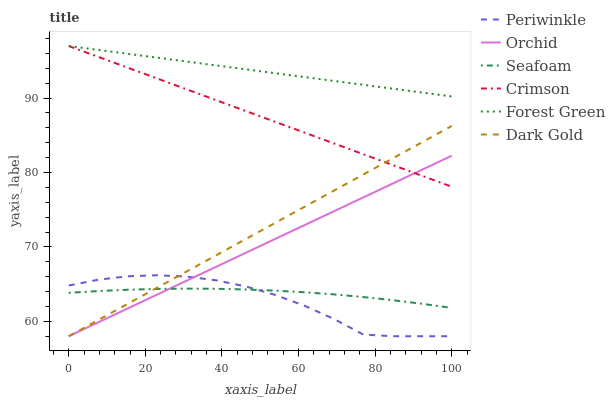Does Periwinkle have the minimum area under the curve?
Answer yes or no. Yes. Does Forest Green have the maximum area under the curve?
Answer yes or no. Yes. Does Seafoam have the minimum area under the curve?
Answer yes or no. No. Does Seafoam have the maximum area under the curve?
Answer yes or no. No. Is Orchid the smoothest?
Answer yes or no. Yes. Is Periwinkle the roughest?
Answer yes or no. Yes. Is Seafoam the smoothest?
Answer yes or no. No. Is Seafoam the roughest?
Answer yes or no. No. Does Dark Gold have the lowest value?
Answer yes or no. Yes. Does Seafoam have the lowest value?
Answer yes or no. No. Does Crimson have the highest value?
Answer yes or no. Yes. Does Seafoam have the highest value?
Answer yes or no. No. Is Orchid less than Forest Green?
Answer yes or no. Yes. Is Forest Green greater than Dark Gold?
Answer yes or no. Yes. Does Dark Gold intersect Crimson?
Answer yes or no. Yes. Is Dark Gold less than Crimson?
Answer yes or no. No. Is Dark Gold greater than Crimson?
Answer yes or no. No. Does Orchid intersect Forest Green?
Answer yes or no. No. 